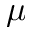<formula> <loc_0><loc_0><loc_500><loc_500>\mu</formula> 